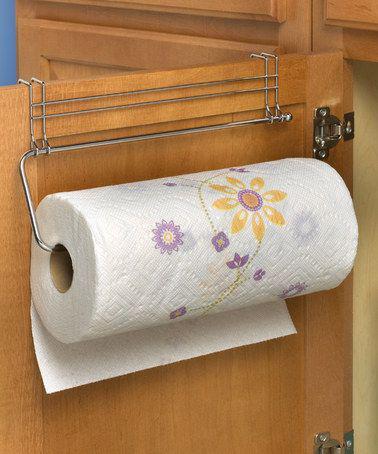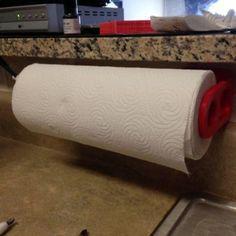The first image is the image on the left, the second image is the image on the right. Analyze the images presented: Is the assertion "One of the images shows brown folded paper towels." valid? Answer yes or no. No. The first image is the image on the left, the second image is the image on the right. Assess this claim about the two images: "Each roll of paper towel is on a roller.". Correct or not? Answer yes or no. Yes. 